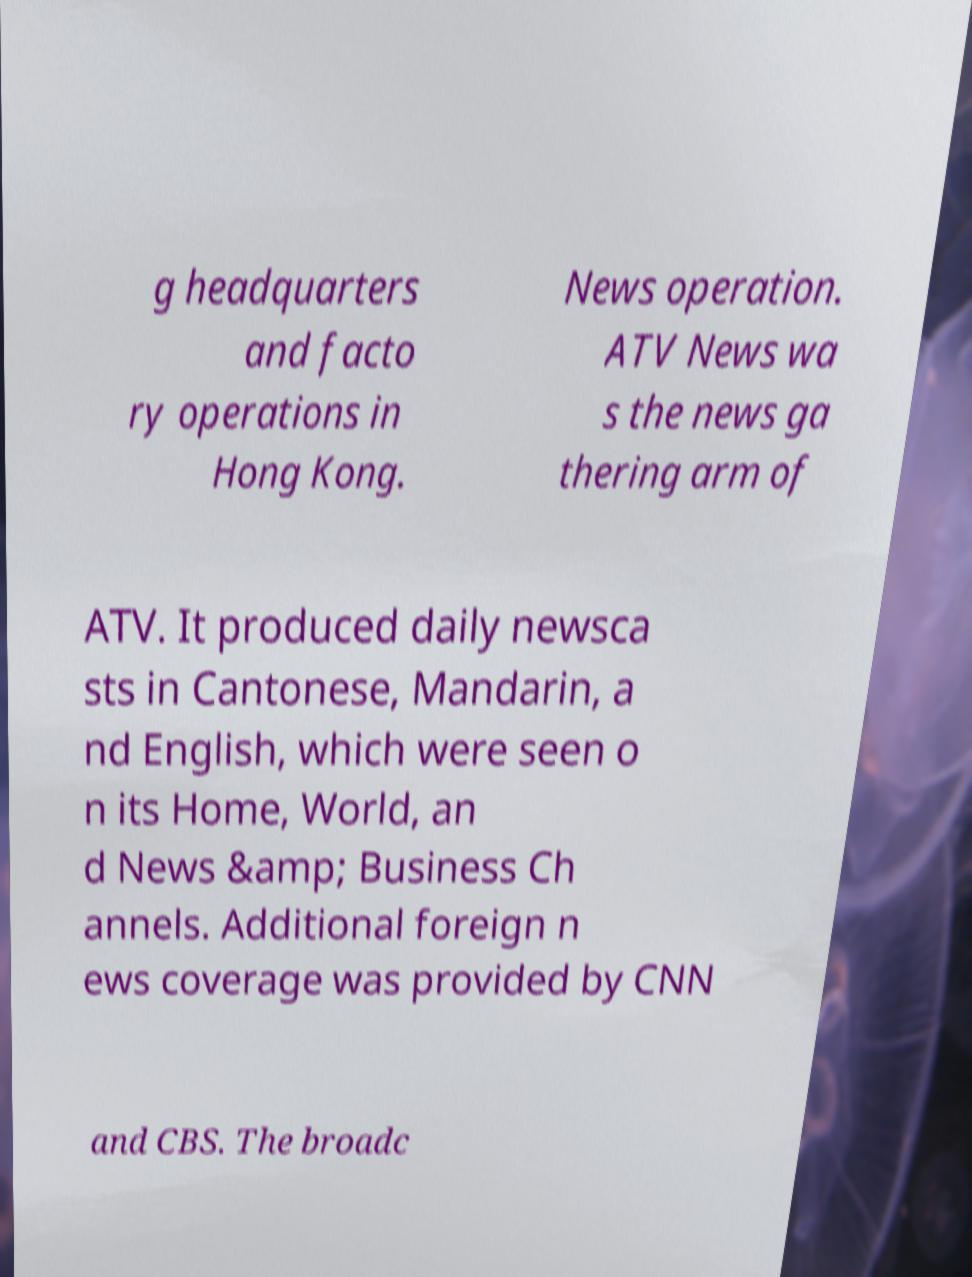Please identify and transcribe the text found in this image. g headquarters and facto ry operations in Hong Kong. News operation. ATV News wa s the news ga thering arm of ATV. It produced daily newsca sts in Cantonese, Mandarin, a nd English, which were seen o n its Home, World, an d News &amp; Business Ch annels. Additional foreign n ews coverage was provided by CNN and CBS. The broadc 